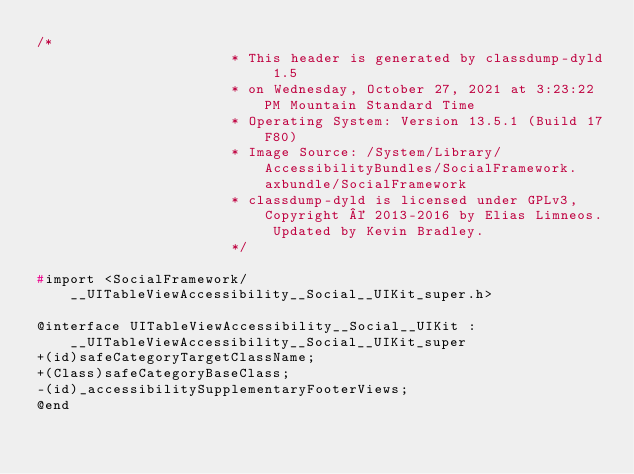Convert code to text. <code><loc_0><loc_0><loc_500><loc_500><_C_>/*
                       * This header is generated by classdump-dyld 1.5
                       * on Wednesday, October 27, 2021 at 3:23:22 PM Mountain Standard Time
                       * Operating System: Version 13.5.1 (Build 17F80)
                       * Image Source: /System/Library/AccessibilityBundles/SocialFramework.axbundle/SocialFramework
                       * classdump-dyld is licensed under GPLv3, Copyright © 2013-2016 by Elias Limneos. Updated by Kevin Bradley.
                       */

#import <SocialFramework/__UITableViewAccessibility__Social__UIKit_super.h>

@interface UITableViewAccessibility__Social__UIKit : __UITableViewAccessibility__Social__UIKit_super
+(id)safeCategoryTargetClassName;
+(Class)safeCategoryBaseClass;
-(id)_accessibilitySupplementaryFooterViews;
@end

</code> 